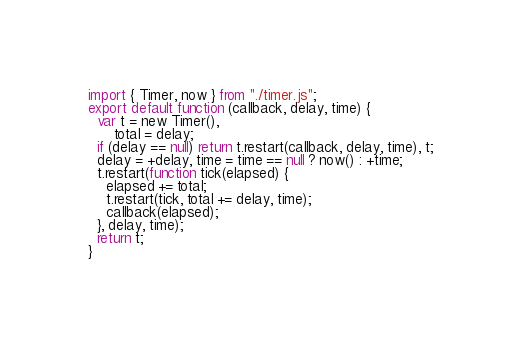<code> <loc_0><loc_0><loc_500><loc_500><_JavaScript_>import { Timer, now } from "./timer.js";
export default function (callback, delay, time) {
  var t = new Timer(),
      total = delay;
  if (delay == null) return t.restart(callback, delay, time), t;
  delay = +delay, time = time == null ? now() : +time;
  t.restart(function tick(elapsed) {
    elapsed += total;
    t.restart(tick, total += delay, time);
    callback(elapsed);
  }, delay, time);
  return t;
}</code> 